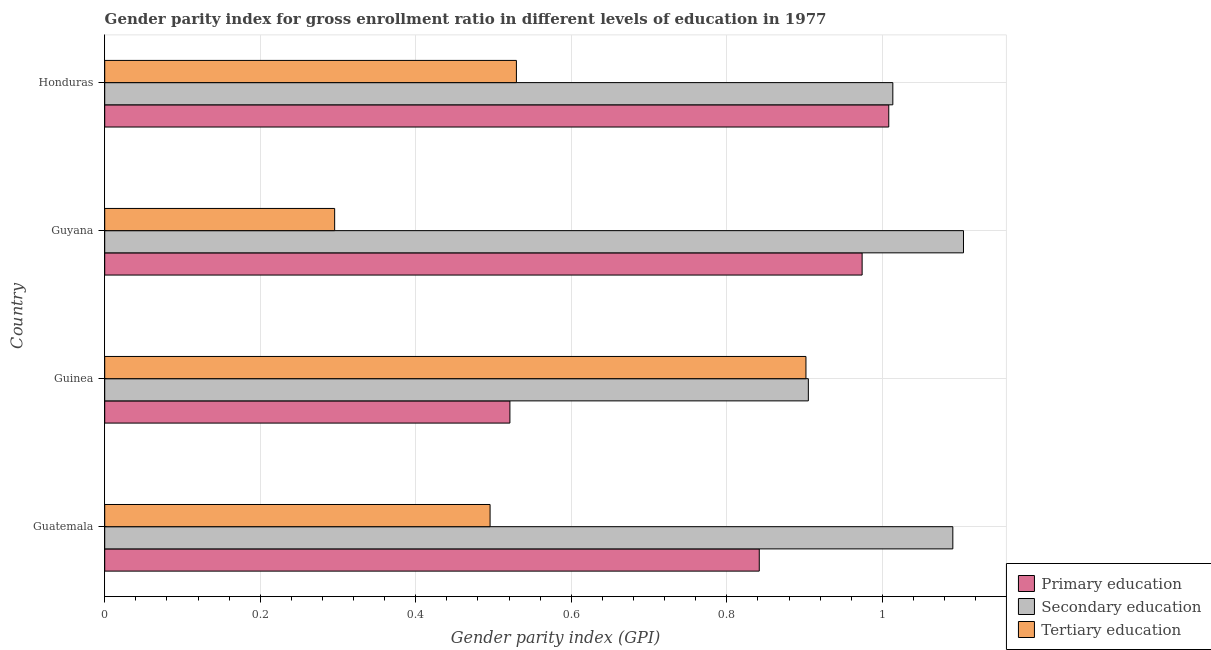How many different coloured bars are there?
Your answer should be very brief. 3. How many groups of bars are there?
Ensure brevity in your answer.  4. Are the number of bars per tick equal to the number of legend labels?
Provide a succinct answer. Yes. What is the label of the 2nd group of bars from the top?
Your answer should be compact. Guyana. In how many cases, is the number of bars for a given country not equal to the number of legend labels?
Provide a short and direct response. 0. What is the gender parity index in primary education in Guyana?
Give a very brief answer. 0.97. Across all countries, what is the maximum gender parity index in tertiary education?
Provide a short and direct response. 0.9. Across all countries, what is the minimum gender parity index in primary education?
Ensure brevity in your answer.  0.52. In which country was the gender parity index in tertiary education maximum?
Make the answer very short. Guinea. In which country was the gender parity index in primary education minimum?
Your response must be concise. Guinea. What is the total gender parity index in secondary education in the graph?
Make the answer very short. 4.11. What is the difference between the gender parity index in tertiary education in Guinea and that in Honduras?
Provide a short and direct response. 0.37. What is the difference between the gender parity index in tertiary education in Guyana and the gender parity index in primary education in Guinea?
Your response must be concise. -0.23. What is the average gender parity index in secondary education per country?
Provide a succinct answer. 1.03. What is the difference between the gender parity index in primary education and gender parity index in tertiary education in Honduras?
Ensure brevity in your answer.  0.48. What is the ratio of the gender parity index in secondary education in Guatemala to that in Guyana?
Make the answer very short. 0.99. Is the difference between the gender parity index in primary education in Guyana and Honduras greater than the difference between the gender parity index in secondary education in Guyana and Honduras?
Offer a terse response. No. What is the difference between the highest and the second highest gender parity index in primary education?
Ensure brevity in your answer.  0.03. What is the difference between the highest and the lowest gender parity index in secondary education?
Ensure brevity in your answer.  0.2. What does the 2nd bar from the top in Guatemala represents?
Offer a terse response. Secondary education. What does the 2nd bar from the bottom in Guyana represents?
Give a very brief answer. Secondary education. Does the graph contain any zero values?
Give a very brief answer. No. Does the graph contain grids?
Offer a very short reply. Yes. How are the legend labels stacked?
Your answer should be compact. Vertical. What is the title of the graph?
Your answer should be compact. Gender parity index for gross enrollment ratio in different levels of education in 1977. What is the label or title of the X-axis?
Your answer should be very brief. Gender parity index (GPI). What is the Gender parity index (GPI) in Primary education in Guatemala?
Ensure brevity in your answer.  0.84. What is the Gender parity index (GPI) of Secondary education in Guatemala?
Your answer should be compact. 1.09. What is the Gender parity index (GPI) of Tertiary education in Guatemala?
Offer a very short reply. 0.5. What is the Gender parity index (GPI) of Primary education in Guinea?
Provide a short and direct response. 0.52. What is the Gender parity index (GPI) in Secondary education in Guinea?
Your response must be concise. 0.9. What is the Gender parity index (GPI) in Tertiary education in Guinea?
Make the answer very short. 0.9. What is the Gender parity index (GPI) of Primary education in Guyana?
Your answer should be compact. 0.97. What is the Gender parity index (GPI) in Secondary education in Guyana?
Your answer should be very brief. 1.1. What is the Gender parity index (GPI) of Tertiary education in Guyana?
Your answer should be compact. 0.3. What is the Gender parity index (GPI) of Primary education in Honduras?
Provide a short and direct response. 1.01. What is the Gender parity index (GPI) of Secondary education in Honduras?
Keep it short and to the point. 1.01. What is the Gender parity index (GPI) of Tertiary education in Honduras?
Your response must be concise. 0.53. Across all countries, what is the maximum Gender parity index (GPI) in Primary education?
Keep it short and to the point. 1.01. Across all countries, what is the maximum Gender parity index (GPI) of Secondary education?
Your answer should be very brief. 1.1. Across all countries, what is the maximum Gender parity index (GPI) in Tertiary education?
Give a very brief answer. 0.9. Across all countries, what is the minimum Gender parity index (GPI) of Primary education?
Your answer should be very brief. 0.52. Across all countries, what is the minimum Gender parity index (GPI) of Secondary education?
Make the answer very short. 0.9. Across all countries, what is the minimum Gender parity index (GPI) of Tertiary education?
Keep it short and to the point. 0.3. What is the total Gender parity index (GPI) in Primary education in the graph?
Offer a terse response. 3.35. What is the total Gender parity index (GPI) in Secondary education in the graph?
Provide a short and direct response. 4.11. What is the total Gender parity index (GPI) in Tertiary education in the graph?
Ensure brevity in your answer.  2.22. What is the difference between the Gender parity index (GPI) in Primary education in Guatemala and that in Guinea?
Provide a succinct answer. 0.32. What is the difference between the Gender parity index (GPI) in Secondary education in Guatemala and that in Guinea?
Give a very brief answer. 0.19. What is the difference between the Gender parity index (GPI) of Tertiary education in Guatemala and that in Guinea?
Provide a succinct answer. -0.41. What is the difference between the Gender parity index (GPI) in Primary education in Guatemala and that in Guyana?
Make the answer very short. -0.13. What is the difference between the Gender parity index (GPI) in Secondary education in Guatemala and that in Guyana?
Your response must be concise. -0.01. What is the difference between the Gender parity index (GPI) of Tertiary education in Guatemala and that in Guyana?
Your response must be concise. 0.2. What is the difference between the Gender parity index (GPI) of Primary education in Guatemala and that in Honduras?
Provide a succinct answer. -0.17. What is the difference between the Gender parity index (GPI) in Secondary education in Guatemala and that in Honduras?
Offer a terse response. 0.08. What is the difference between the Gender parity index (GPI) of Tertiary education in Guatemala and that in Honduras?
Offer a very short reply. -0.03. What is the difference between the Gender parity index (GPI) in Primary education in Guinea and that in Guyana?
Your response must be concise. -0.45. What is the difference between the Gender parity index (GPI) in Secondary education in Guinea and that in Guyana?
Offer a very short reply. -0.2. What is the difference between the Gender parity index (GPI) in Tertiary education in Guinea and that in Guyana?
Ensure brevity in your answer.  0.61. What is the difference between the Gender parity index (GPI) in Primary education in Guinea and that in Honduras?
Provide a succinct answer. -0.49. What is the difference between the Gender parity index (GPI) of Secondary education in Guinea and that in Honduras?
Make the answer very short. -0.11. What is the difference between the Gender parity index (GPI) of Tertiary education in Guinea and that in Honduras?
Give a very brief answer. 0.37. What is the difference between the Gender parity index (GPI) in Primary education in Guyana and that in Honduras?
Offer a terse response. -0.03. What is the difference between the Gender parity index (GPI) in Secondary education in Guyana and that in Honduras?
Keep it short and to the point. 0.09. What is the difference between the Gender parity index (GPI) of Tertiary education in Guyana and that in Honduras?
Keep it short and to the point. -0.23. What is the difference between the Gender parity index (GPI) of Primary education in Guatemala and the Gender parity index (GPI) of Secondary education in Guinea?
Your answer should be very brief. -0.06. What is the difference between the Gender parity index (GPI) in Primary education in Guatemala and the Gender parity index (GPI) in Tertiary education in Guinea?
Make the answer very short. -0.06. What is the difference between the Gender parity index (GPI) of Secondary education in Guatemala and the Gender parity index (GPI) of Tertiary education in Guinea?
Your answer should be very brief. 0.19. What is the difference between the Gender parity index (GPI) in Primary education in Guatemala and the Gender parity index (GPI) in Secondary education in Guyana?
Make the answer very short. -0.26. What is the difference between the Gender parity index (GPI) of Primary education in Guatemala and the Gender parity index (GPI) of Tertiary education in Guyana?
Your answer should be very brief. 0.55. What is the difference between the Gender parity index (GPI) of Secondary education in Guatemala and the Gender parity index (GPI) of Tertiary education in Guyana?
Make the answer very short. 0.8. What is the difference between the Gender parity index (GPI) in Primary education in Guatemala and the Gender parity index (GPI) in Secondary education in Honduras?
Offer a terse response. -0.17. What is the difference between the Gender parity index (GPI) in Primary education in Guatemala and the Gender parity index (GPI) in Tertiary education in Honduras?
Ensure brevity in your answer.  0.31. What is the difference between the Gender parity index (GPI) of Secondary education in Guatemala and the Gender parity index (GPI) of Tertiary education in Honduras?
Ensure brevity in your answer.  0.56. What is the difference between the Gender parity index (GPI) in Primary education in Guinea and the Gender parity index (GPI) in Secondary education in Guyana?
Provide a short and direct response. -0.58. What is the difference between the Gender parity index (GPI) in Primary education in Guinea and the Gender parity index (GPI) in Tertiary education in Guyana?
Provide a short and direct response. 0.23. What is the difference between the Gender parity index (GPI) in Secondary education in Guinea and the Gender parity index (GPI) in Tertiary education in Guyana?
Give a very brief answer. 0.61. What is the difference between the Gender parity index (GPI) of Primary education in Guinea and the Gender parity index (GPI) of Secondary education in Honduras?
Provide a succinct answer. -0.49. What is the difference between the Gender parity index (GPI) of Primary education in Guinea and the Gender parity index (GPI) of Tertiary education in Honduras?
Make the answer very short. -0.01. What is the difference between the Gender parity index (GPI) in Secondary education in Guinea and the Gender parity index (GPI) in Tertiary education in Honduras?
Your answer should be compact. 0.38. What is the difference between the Gender parity index (GPI) of Primary education in Guyana and the Gender parity index (GPI) of Secondary education in Honduras?
Make the answer very short. -0.04. What is the difference between the Gender parity index (GPI) in Primary education in Guyana and the Gender parity index (GPI) in Tertiary education in Honduras?
Make the answer very short. 0.44. What is the difference between the Gender parity index (GPI) of Secondary education in Guyana and the Gender parity index (GPI) of Tertiary education in Honduras?
Your response must be concise. 0.57. What is the average Gender parity index (GPI) of Primary education per country?
Provide a short and direct response. 0.84. What is the average Gender parity index (GPI) of Secondary education per country?
Make the answer very short. 1.03. What is the average Gender parity index (GPI) in Tertiary education per country?
Offer a terse response. 0.56. What is the difference between the Gender parity index (GPI) in Primary education and Gender parity index (GPI) in Secondary education in Guatemala?
Keep it short and to the point. -0.25. What is the difference between the Gender parity index (GPI) of Primary education and Gender parity index (GPI) of Tertiary education in Guatemala?
Ensure brevity in your answer.  0.35. What is the difference between the Gender parity index (GPI) of Secondary education and Gender parity index (GPI) of Tertiary education in Guatemala?
Provide a succinct answer. 0.6. What is the difference between the Gender parity index (GPI) of Primary education and Gender parity index (GPI) of Secondary education in Guinea?
Your answer should be very brief. -0.38. What is the difference between the Gender parity index (GPI) in Primary education and Gender parity index (GPI) in Tertiary education in Guinea?
Give a very brief answer. -0.38. What is the difference between the Gender parity index (GPI) in Secondary education and Gender parity index (GPI) in Tertiary education in Guinea?
Offer a terse response. 0. What is the difference between the Gender parity index (GPI) of Primary education and Gender parity index (GPI) of Secondary education in Guyana?
Your response must be concise. -0.13. What is the difference between the Gender parity index (GPI) of Primary education and Gender parity index (GPI) of Tertiary education in Guyana?
Your answer should be compact. 0.68. What is the difference between the Gender parity index (GPI) in Secondary education and Gender parity index (GPI) in Tertiary education in Guyana?
Make the answer very short. 0.81. What is the difference between the Gender parity index (GPI) of Primary education and Gender parity index (GPI) of Secondary education in Honduras?
Your answer should be compact. -0.01. What is the difference between the Gender parity index (GPI) in Primary education and Gender parity index (GPI) in Tertiary education in Honduras?
Your answer should be very brief. 0.48. What is the difference between the Gender parity index (GPI) in Secondary education and Gender parity index (GPI) in Tertiary education in Honduras?
Give a very brief answer. 0.48. What is the ratio of the Gender parity index (GPI) of Primary education in Guatemala to that in Guinea?
Make the answer very short. 1.62. What is the ratio of the Gender parity index (GPI) in Secondary education in Guatemala to that in Guinea?
Provide a short and direct response. 1.21. What is the ratio of the Gender parity index (GPI) in Tertiary education in Guatemala to that in Guinea?
Provide a succinct answer. 0.55. What is the ratio of the Gender parity index (GPI) in Primary education in Guatemala to that in Guyana?
Give a very brief answer. 0.86. What is the ratio of the Gender parity index (GPI) in Secondary education in Guatemala to that in Guyana?
Keep it short and to the point. 0.99. What is the ratio of the Gender parity index (GPI) of Tertiary education in Guatemala to that in Guyana?
Offer a very short reply. 1.68. What is the ratio of the Gender parity index (GPI) of Primary education in Guatemala to that in Honduras?
Your answer should be very brief. 0.83. What is the ratio of the Gender parity index (GPI) of Secondary education in Guatemala to that in Honduras?
Give a very brief answer. 1.08. What is the ratio of the Gender parity index (GPI) of Tertiary education in Guatemala to that in Honduras?
Make the answer very short. 0.94. What is the ratio of the Gender parity index (GPI) in Primary education in Guinea to that in Guyana?
Provide a succinct answer. 0.54. What is the ratio of the Gender parity index (GPI) of Secondary education in Guinea to that in Guyana?
Keep it short and to the point. 0.82. What is the ratio of the Gender parity index (GPI) of Tertiary education in Guinea to that in Guyana?
Ensure brevity in your answer.  3.05. What is the ratio of the Gender parity index (GPI) in Primary education in Guinea to that in Honduras?
Offer a terse response. 0.52. What is the ratio of the Gender parity index (GPI) in Secondary education in Guinea to that in Honduras?
Your answer should be compact. 0.89. What is the ratio of the Gender parity index (GPI) in Tertiary education in Guinea to that in Honduras?
Your response must be concise. 1.7. What is the ratio of the Gender parity index (GPI) in Primary education in Guyana to that in Honduras?
Make the answer very short. 0.97. What is the ratio of the Gender parity index (GPI) of Secondary education in Guyana to that in Honduras?
Ensure brevity in your answer.  1.09. What is the ratio of the Gender parity index (GPI) in Tertiary education in Guyana to that in Honduras?
Offer a terse response. 0.56. What is the difference between the highest and the second highest Gender parity index (GPI) of Primary education?
Offer a very short reply. 0.03. What is the difference between the highest and the second highest Gender parity index (GPI) of Secondary education?
Make the answer very short. 0.01. What is the difference between the highest and the second highest Gender parity index (GPI) in Tertiary education?
Your answer should be compact. 0.37. What is the difference between the highest and the lowest Gender parity index (GPI) in Primary education?
Offer a terse response. 0.49. What is the difference between the highest and the lowest Gender parity index (GPI) of Secondary education?
Offer a terse response. 0.2. What is the difference between the highest and the lowest Gender parity index (GPI) of Tertiary education?
Give a very brief answer. 0.61. 